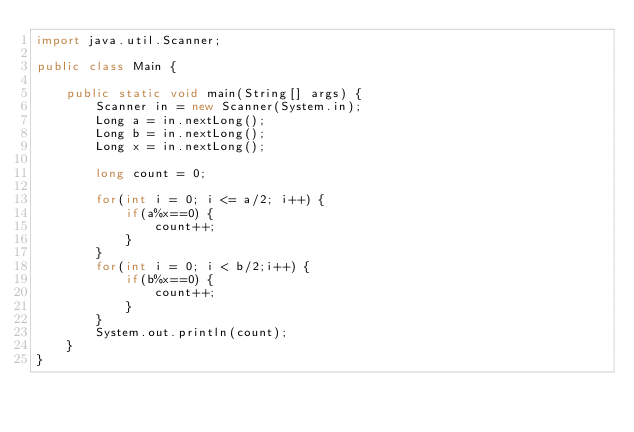<code> <loc_0><loc_0><loc_500><loc_500><_Java_>import java.util.Scanner;

public class Main {

	public static void main(String[] args) {
		Scanner in = new Scanner(System.in);
		Long a = in.nextLong();
		Long b = in.nextLong();
		Long x = in.nextLong();

		long count = 0;
		
		for(int i = 0; i <= a/2; i++) {
			if(a%x==0) {
				count++;
			}
		}
		for(int i = 0; i < b/2;i++) {
			if(b%x==0) {
				count++;
			}
		}
		System.out.println(count);
	}
}</code> 